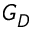Convert formula to latex. <formula><loc_0><loc_0><loc_500><loc_500>G _ { D }</formula> 